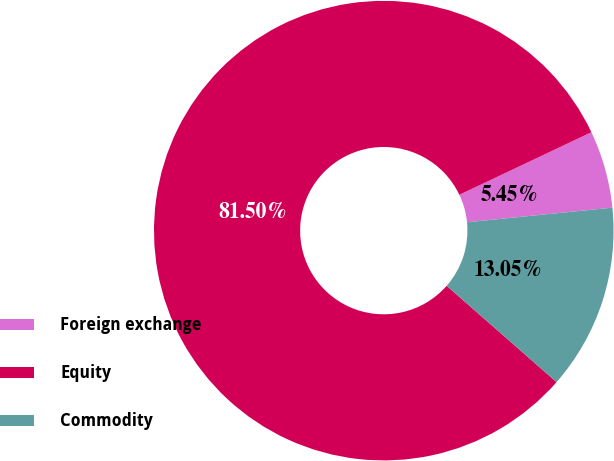Convert chart to OTSL. <chart><loc_0><loc_0><loc_500><loc_500><pie_chart><fcel>Foreign exchange<fcel>Equity<fcel>Commodity<nl><fcel>5.45%<fcel>81.5%<fcel>13.05%<nl></chart> 